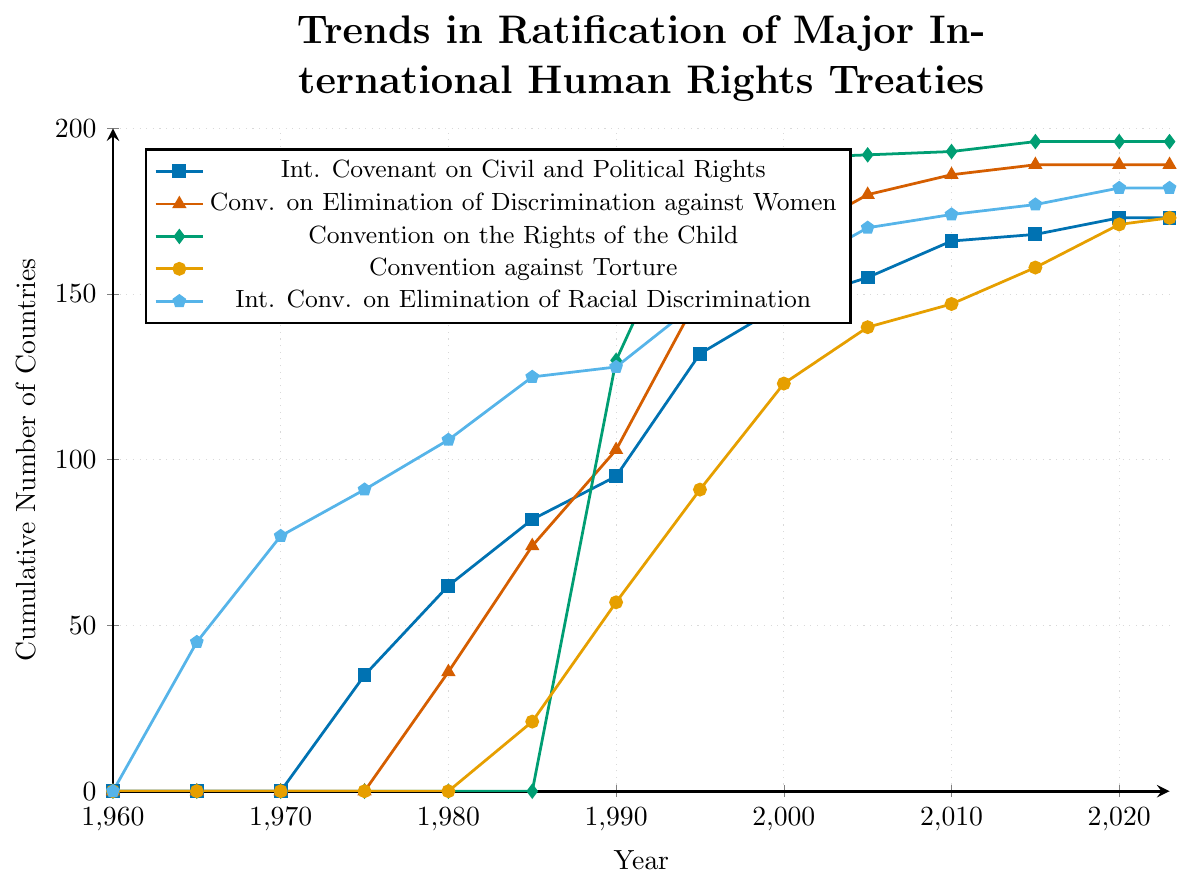What is the total number of countries that ratified the Convention on the Rights of the Child by 2023? Look at the graph where the 'Convention on the Rights of the Child' is marked with diamonds and observe the value at the year 2023. The cumulative number of countries is 196.
Answer: 196 Which treaty had the fastest increase in ratification between 1980 and 1990? Compare the slopes of the lines for each treaty between 1980 and 1990. Each line's steepness indicates the rate of ratification. The Convention on the Rights of the Child, marked with diamonds, had the most significant increase, going from 0 in 1985 to 130 in 1990.
Answer: Convention on the Rights of the Child How has the ratification of the International Covenant on Civil and Political Rights changed from 1975 to 2023? Observe the plot for the 'International Covenant on Civil and Political Rights' (marked with squares) and track its progress from 1975 to 2023. The count increased from 35 to 173 in that period.
Answer: Increased by 138 Which treaty reached close to its peak ratification number by the year 2000? Compare the values for each treaty around the year 2000. The 'Convention on the Rights of the Child' (marked with diamonds) had reached nearly its peak value of 196 by 2000, having 191 ratifications.
Answer: Convention on the Rights of the Child When did the Convention against Torture first see significant ratification? Look for the first significant uptick in the plot for the 'Convention against Torture' (marked with circles) and identify the corresponding period. The first significant increase occurs between 1985 (21 countries) and 1990 (57 countries).
Answer: Between 1985 and 1990 Compare the cumulative number of countries that ratified the Convention on the Elimination of All Forms of Discrimination against Women and the Convention against Torture by 2023. Check the end values in 2023 for both treaties in the plot. The 'Convention on the Elimination of Discrimination against Women' (marked with triangles) has 189 ratifications, and the 'Convention against Torture' (marked with circles) has 173 ratifications.
Answer: The Convention on the Elimination of All Forms of Discrimination against Women has 16 more ratifications than the Convention against Torture What is the trend in the ratification of the International Convention on the Elimination of All Forms of Racial Discrimination from 1965 to 1970? Look at the section of the plot relating to the 'International Convention on the Elimination of Racial Discrimination' (marked with pentagons) between 1965 and 1970. The number increases from 45 to 77.
Answer: Increased by 32 Which treaty had the most steady increase in ratification from 1960 to 2023? Examine the lines for each treaty to see which is the most linear, indicating a steady increase. The 'International Convention on the Elimination of All Forms of Racial Discrimination' (marked with pentagons) shows the most consistent incremental growth.
Answer: International Convention on the Elimination of All Forms of Racial Discrimination Between 1990 and 1995, which treaty saw the smallest increase in the number of ratifying countries? Compare the increase in number of ratifications for each treaty between 1990 and 1995. The 'International Convention on the Elimination of All Forms of Racial Discrimination' increased from 128 to 148, a change of 20, which is smaller than other treaties in that period.
Answer: International Convention on the Elimination of All Forms of Racial Discrimination 